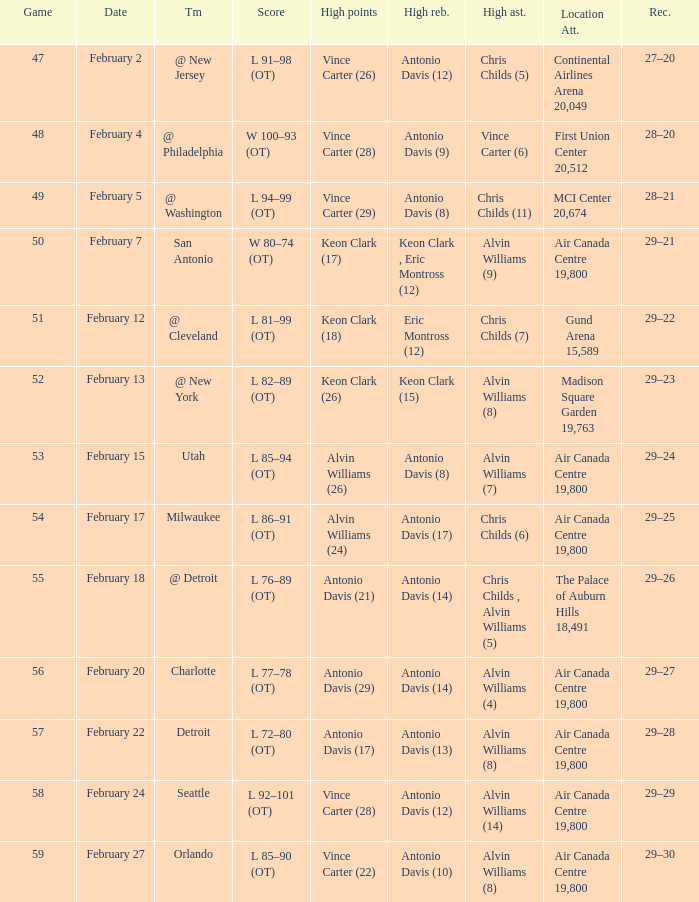What is the Record when the high rebounds was Antonio Davis (9)? 28–20. 